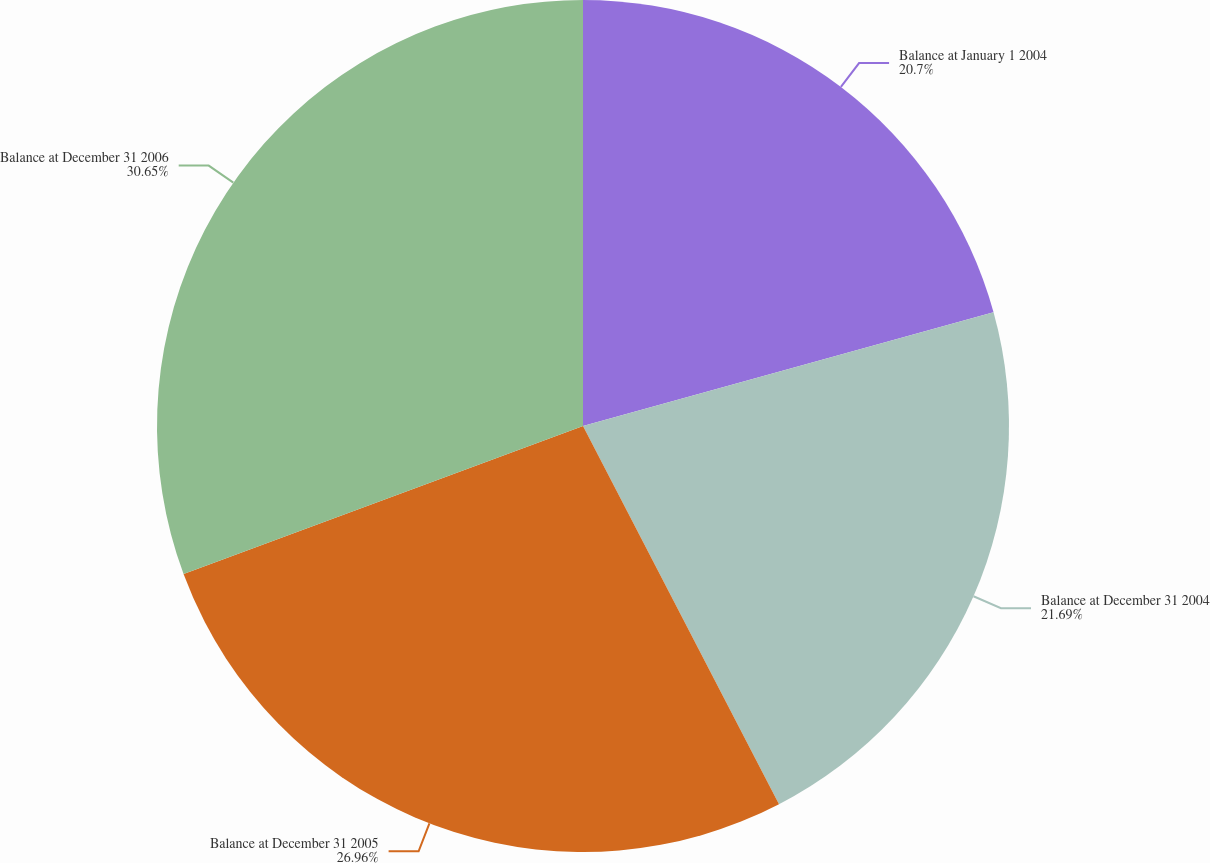Convert chart to OTSL. <chart><loc_0><loc_0><loc_500><loc_500><pie_chart><fcel>Balance at January 1 2004<fcel>Balance at December 31 2004<fcel>Balance at December 31 2005<fcel>Balance at December 31 2006<nl><fcel>20.7%<fcel>21.69%<fcel>26.96%<fcel>30.65%<nl></chart> 